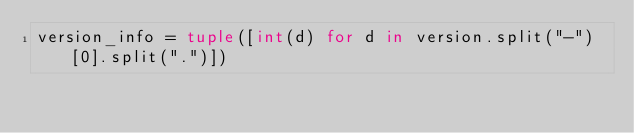<code> <loc_0><loc_0><loc_500><loc_500><_Python_>version_info = tuple([int(d) for d in version.split("-")[0].split(".")])
</code> 